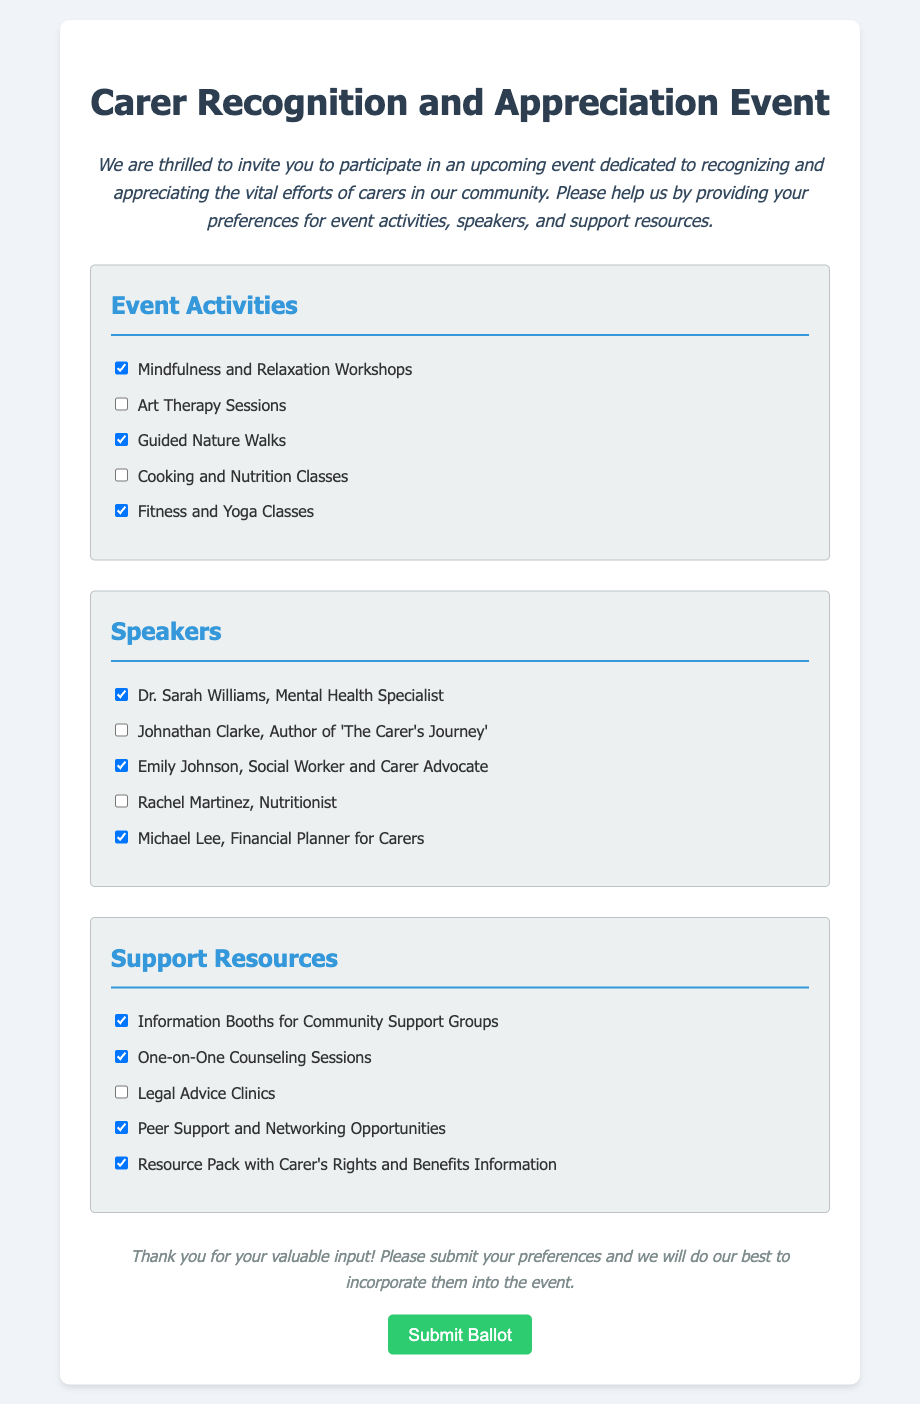What is the title of the event? The title of the event is mentioned at the top of the document as "Carer Recognition and Appreciation Event."
Answer: Carer Recognition and Appreciation Event How many event activities are checked by default? The document lists five event activities, three of which are checked by default, making it a total of three checked activities.
Answer: 3 Who is a speaker listed for the event? One of the speakers listed is "Dr. Sarah Williams, Mental Health Specialist," mentioned in the speakers section.
Answer: Dr. Sarah Williams, Mental Health Specialist What support resource is included for legal advice? The document lists "Legal Advice Clinics" as one of the support resources, indicating the type of support offered.
Answer: Legal Advice Clinics Which activity includes fitness? "Fitness and Yoga Classes" is specifically mentioned as an activity that includes fitness, found in the event activities section.
Answer: Fitness and Yoga Classes Who is a financial planner for carers listed as a speaker? The document mentions "Michael Lee, Financial Planner for Carers" in the speakers section.
Answer: Michael Lee, Financial Planner for Carers What is included in the message at the end of the document? The message encourages input and states gratitude, with a focus on submitting preferences to incorporate them into the event.
Answer: Thank you for your valuable input! How many support resources are checked by default? The document presents a total of five support resources, with four checked by default, indicating the preference level.
Answer: 4 What is the purpose of the event? The purpose is stated in the introduction as an event dedicated to recognizing and appreciating the vital efforts of carers in the community.
Answer: Recognizing and appreciating efforts of carers 